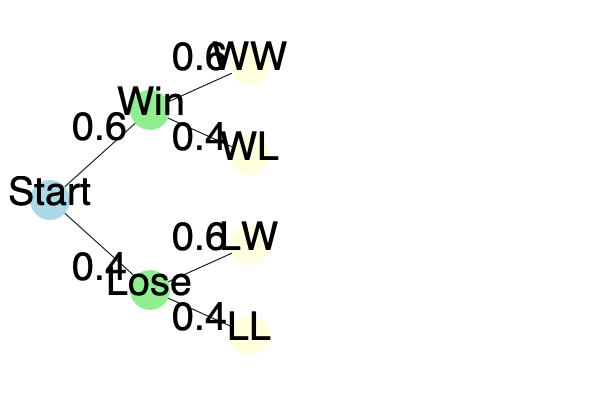Based on historical data, the Wartburg Knights have a 60% chance of winning each game. The decision tree shows the probabilities for outcomes of two consecutive games. What is the probability that the Knights will win exactly one game out of the two? Let's approach this step-by-step:

1) There are two ways to win exactly one game out of two:
   a) Win the first game and lose the second (WL)
   b) Lose the first game and win the second (LW)

2) Let's calculate the probability of each scenario:

   a) P(WL) = P(W) × P(L)
      P(WL) = 0.6 × 0.4 = 0.24

   b) P(LW) = P(L) × P(W)
      P(LW) = 0.4 × 0.6 = 0.24

3) The probability of winning exactly one game is the sum of these two probabilities:

   P(winning exactly one game) = P(WL) + P(LW)
                                = 0.24 + 0.24
                                = 0.48

4) We can verify this result:
   P(WW) = 0.6 × 0.6 = 0.36
   P(WL) = 0.6 × 0.4 = 0.24
   P(LW) = 0.4 × 0.6 = 0.24
   P(LL) = 0.4 × 0.4 = 0.16
   
   The sum of all probabilities is 0.36 + 0.24 + 0.24 + 0.16 = 1, which confirms our calculation.

Therefore, the probability that the Wartburg Knights will win exactly one game out of the two is 0.48 or 48%.
Answer: 0.48 